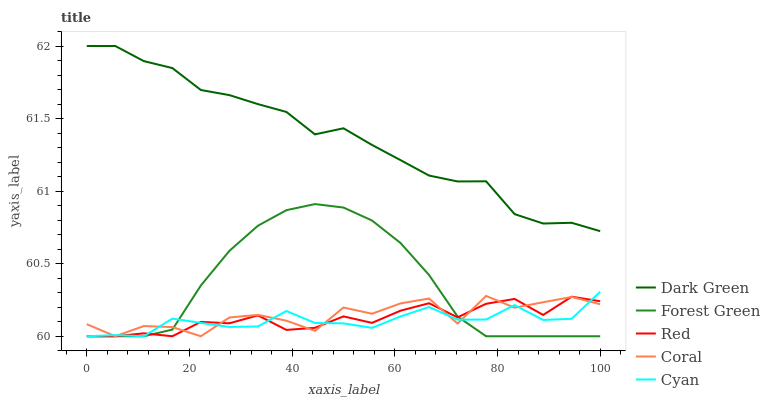Does Cyan have the minimum area under the curve?
Answer yes or no. Yes. Does Dark Green have the maximum area under the curve?
Answer yes or no. Yes. Does Forest Green have the minimum area under the curve?
Answer yes or no. No. Does Forest Green have the maximum area under the curve?
Answer yes or no. No. Is Forest Green the smoothest?
Answer yes or no. Yes. Is Coral the roughest?
Answer yes or no. Yes. Is Coral the smoothest?
Answer yes or no. No. Is Forest Green the roughest?
Answer yes or no. No. Does Dark Green have the lowest value?
Answer yes or no. No. Does Dark Green have the highest value?
Answer yes or no. Yes. Does Forest Green have the highest value?
Answer yes or no. No. Is Red less than Dark Green?
Answer yes or no. Yes. Is Dark Green greater than Forest Green?
Answer yes or no. Yes. Does Red intersect Dark Green?
Answer yes or no. No. 